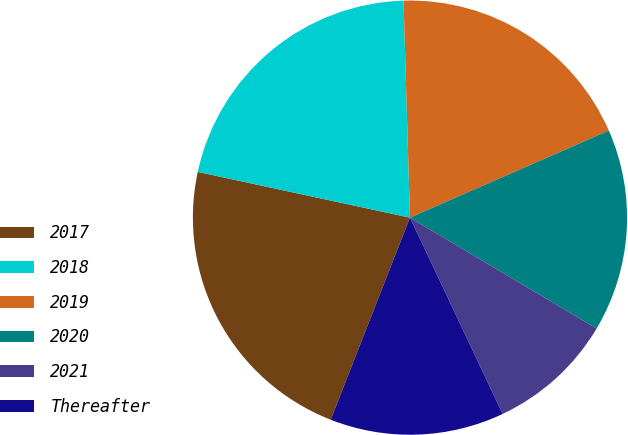Convert chart to OTSL. <chart><loc_0><loc_0><loc_500><loc_500><pie_chart><fcel>2017<fcel>2018<fcel>2019<fcel>2020<fcel>2021<fcel>Thereafter<nl><fcel>22.43%<fcel>21.15%<fcel>18.91%<fcel>15.1%<fcel>9.45%<fcel>12.97%<nl></chart> 